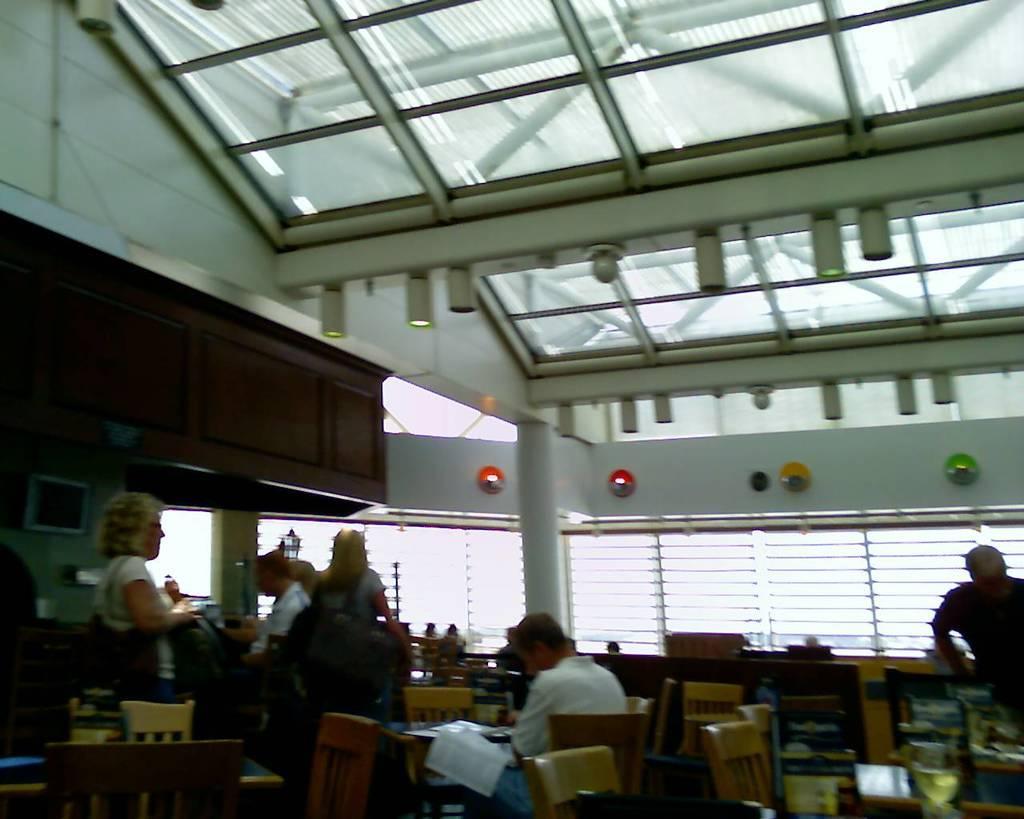In one or two sentences, can you explain what this image depicts? In this picture there are a group of people standing here and person sitting on the chair and tables and empty chair and in the background is a pole and window 